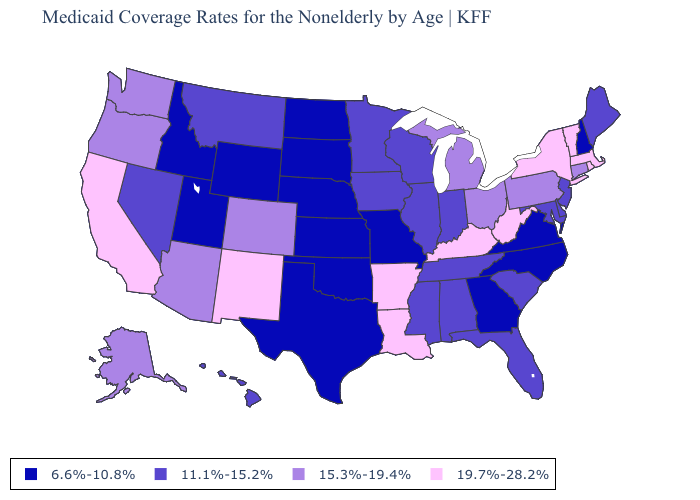Name the states that have a value in the range 15.3%-19.4%?
Concise answer only. Alaska, Arizona, Colorado, Connecticut, Michigan, Ohio, Oregon, Pennsylvania, Washington. What is the value of Iowa?
Be succinct. 11.1%-15.2%. What is the value of New Hampshire?
Concise answer only. 6.6%-10.8%. Name the states that have a value in the range 19.7%-28.2%?
Be succinct. Arkansas, California, Kentucky, Louisiana, Massachusetts, New Mexico, New York, Rhode Island, Vermont, West Virginia. Name the states that have a value in the range 19.7%-28.2%?
Give a very brief answer. Arkansas, California, Kentucky, Louisiana, Massachusetts, New Mexico, New York, Rhode Island, Vermont, West Virginia. Name the states that have a value in the range 19.7%-28.2%?
Write a very short answer. Arkansas, California, Kentucky, Louisiana, Massachusetts, New Mexico, New York, Rhode Island, Vermont, West Virginia. Among the states that border Rhode Island , which have the highest value?
Quick response, please. Massachusetts. What is the lowest value in the MidWest?
Answer briefly. 6.6%-10.8%. Name the states that have a value in the range 6.6%-10.8%?
Give a very brief answer. Georgia, Idaho, Kansas, Missouri, Nebraska, New Hampshire, North Carolina, North Dakota, Oklahoma, South Dakota, Texas, Utah, Virginia, Wyoming. Does Alaska have the same value as Arizona?
Write a very short answer. Yes. What is the value of Ohio?
Quick response, please. 15.3%-19.4%. Among the states that border Iowa , which have the highest value?
Be succinct. Illinois, Minnesota, Wisconsin. What is the value of Massachusetts?
Concise answer only. 19.7%-28.2%. Among the states that border California , which have the highest value?
Short answer required. Arizona, Oregon. 